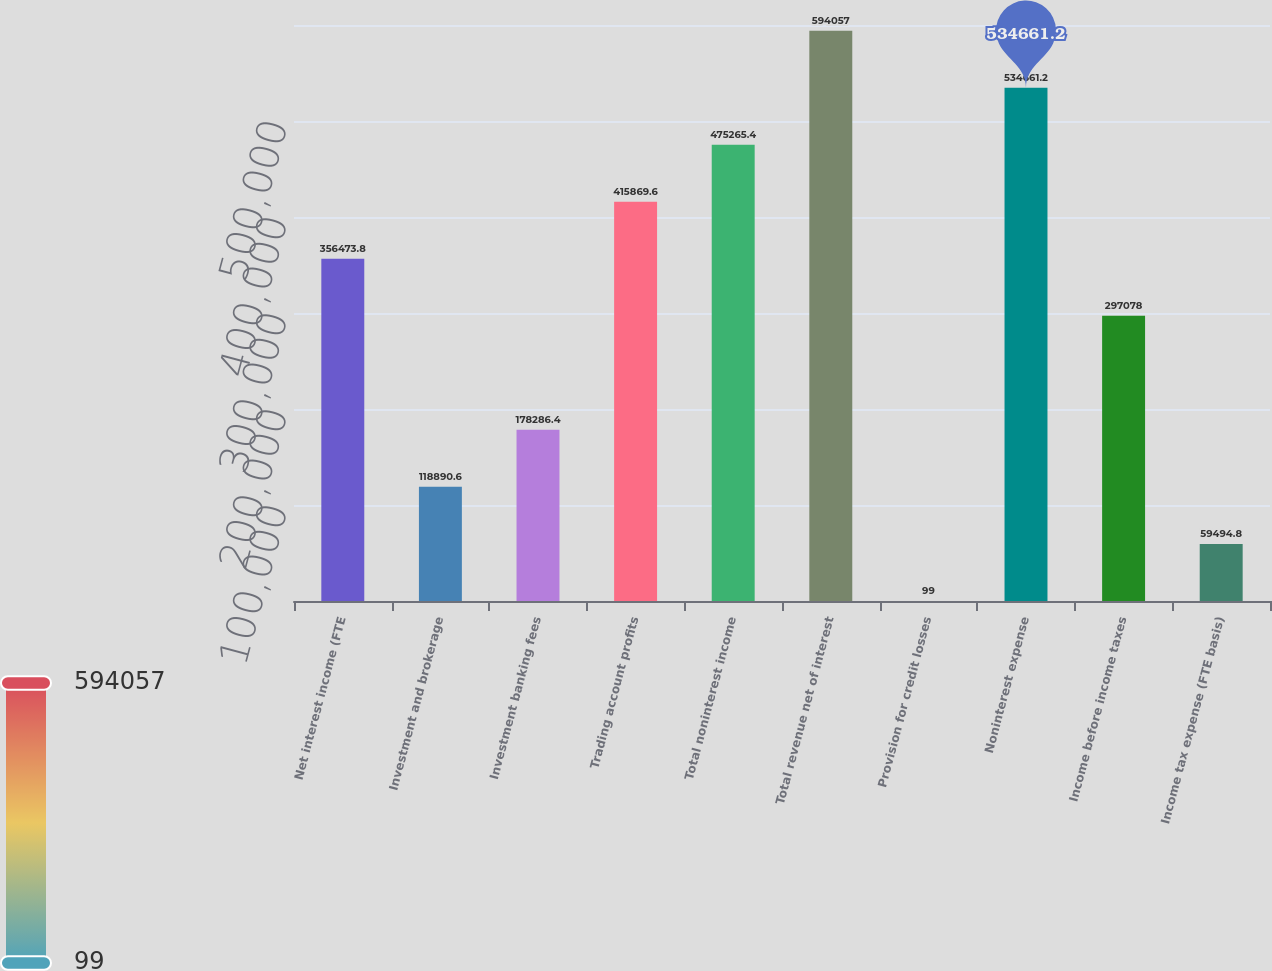<chart> <loc_0><loc_0><loc_500><loc_500><bar_chart><fcel>Net interest income (FTE<fcel>Investment and brokerage<fcel>Investment banking fees<fcel>Trading account profits<fcel>Total noninterest income<fcel>Total revenue net of interest<fcel>Provision for credit losses<fcel>Noninterest expense<fcel>Income before income taxes<fcel>Income tax expense (FTE basis)<nl><fcel>356474<fcel>118891<fcel>178286<fcel>415870<fcel>475265<fcel>594057<fcel>99<fcel>534661<fcel>297078<fcel>59494.8<nl></chart> 